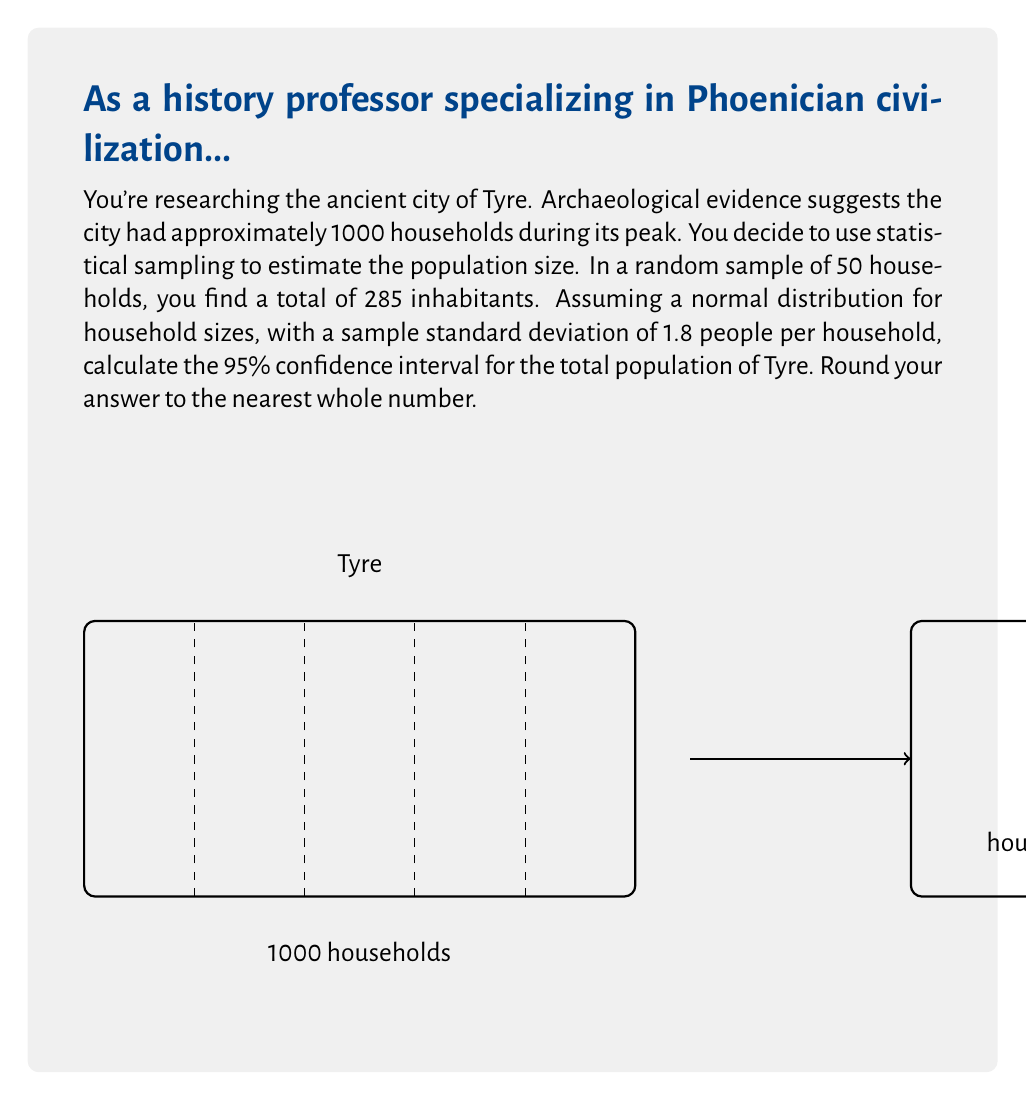Give your solution to this math problem. Let's approach this step-by-step:

1) First, we calculate the mean household size from our sample:
   $\bar{x} = \frac{285}{50} = 5.7$ people per household

2) We know the sample size (n) is 50, and the sample standard deviation (s) is 1.8.

3) For a 95% confidence interval, we use a z-score of 1.96.

4) The formula for the confidence interval of the mean is:

   $$\bar{x} \pm z \cdot \frac{s}{\sqrt{n}}$$

5) Plugging in our values:

   $$5.7 \pm 1.96 \cdot \frac{1.8}{\sqrt{50}}$$

6) Simplifying:

   $$5.7 \pm 1.96 \cdot 0.2546 = 5.7 \pm 0.4990$$

7) This gives us a confidence interval for the mean household size:
   (5.2010, 6.1990)

8) To estimate the total population, we multiply these bounds by the total number of households (1000):

   Lower bound: $5.2010 \cdot 1000 = 5201$
   Upper bound: $6.1990 \cdot 1000 = 6199$

9) Rounding to the nearest whole number, our 95% confidence interval for the total population is:
   (5201, 6199)
Answer: (5201, 6199) 